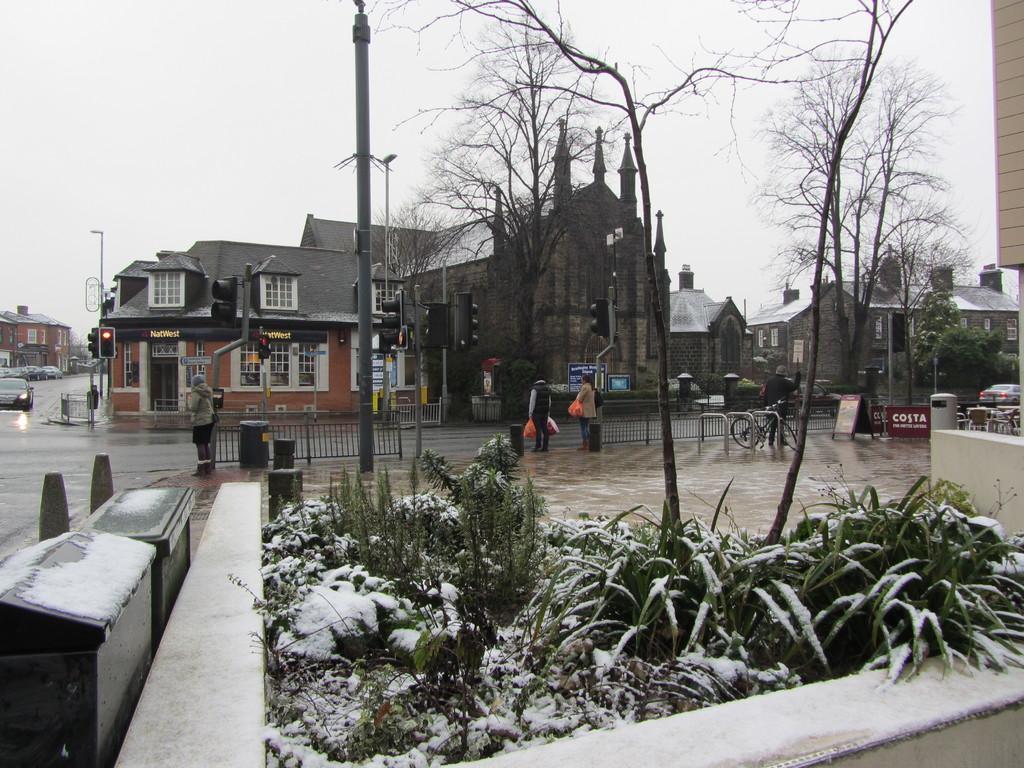Can you describe this image briefly? In this image we can see a few plants, trees, snow on the plants, there are a few people standing on the pavement and holding bags in their hands, there is a car on the road, there are few buildings, a bicycle, iron fence, a board and iron boxes. 